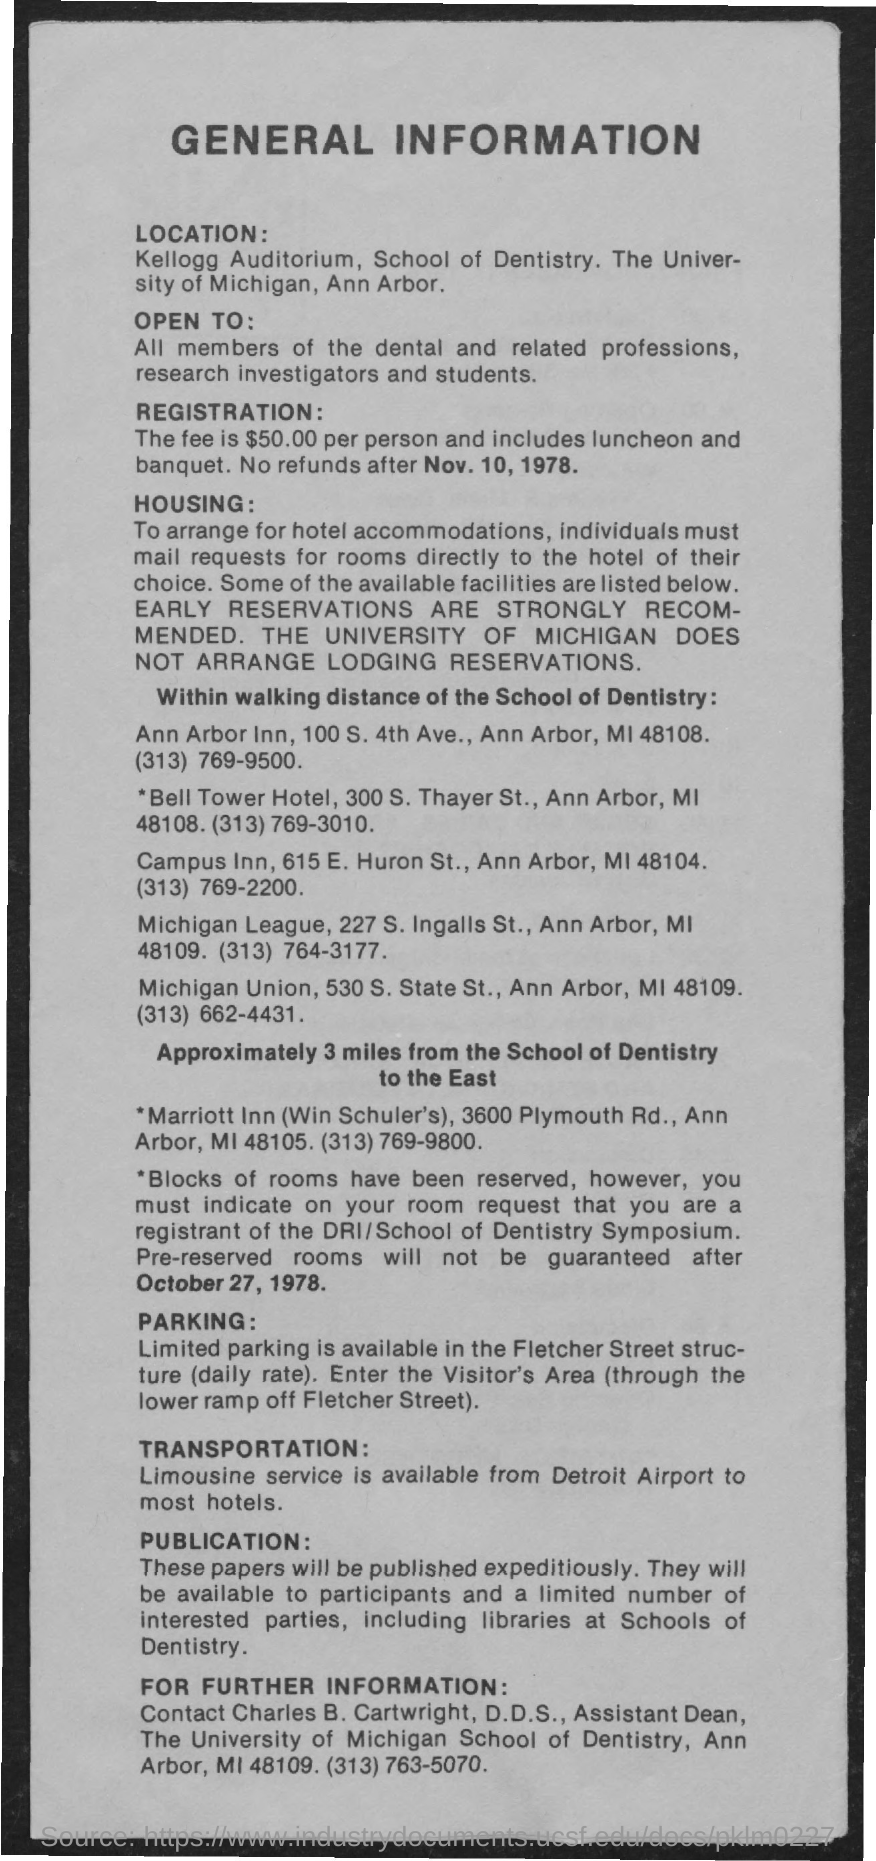List a handful of essential elements in this visual. Parking is available at Fletcher Street Structure. Kellogg Auditorium is mentioned in the location details. The registration fee for each person is $50. There is a limousine service available for transportation. The Dean Assistant at the University of Michigan School of Dentistry is Charles B. Cartwright. 